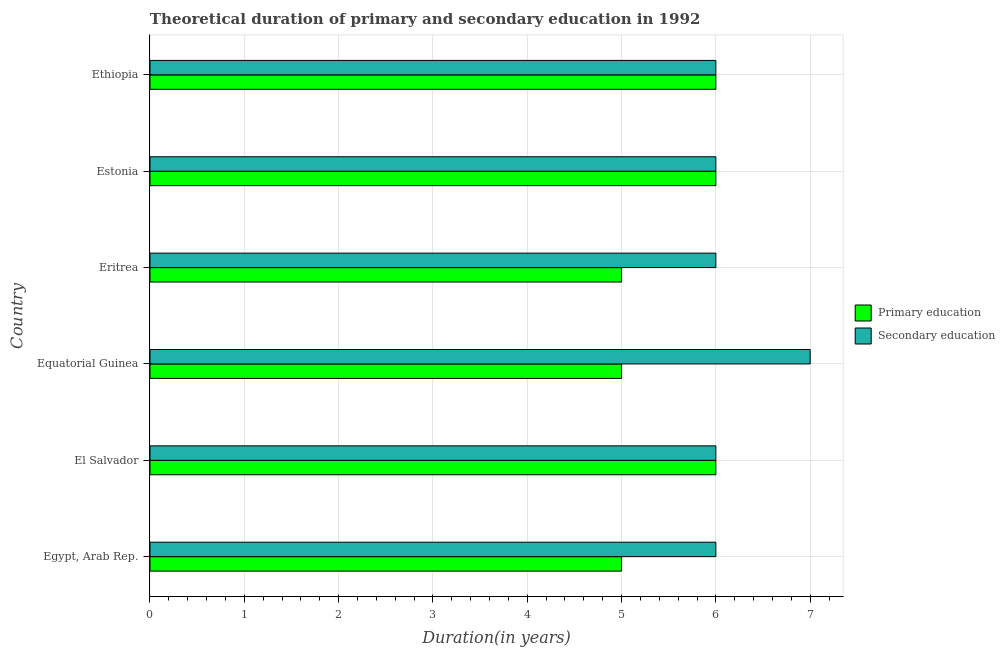How many groups of bars are there?
Keep it short and to the point. 6. Are the number of bars per tick equal to the number of legend labels?
Give a very brief answer. Yes. Are the number of bars on each tick of the Y-axis equal?
Give a very brief answer. Yes. How many bars are there on the 5th tick from the top?
Keep it short and to the point. 2. How many bars are there on the 4th tick from the bottom?
Your answer should be very brief. 2. What is the label of the 1st group of bars from the top?
Your answer should be compact. Ethiopia. In how many cases, is the number of bars for a given country not equal to the number of legend labels?
Give a very brief answer. 0. What is the duration of primary education in Eritrea?
Make the answer very short. 5. Across all countries, what is the maximum duration of secondary education?
Provide a short and direct response. 7. Across all countries, what is the minimum duration of primary education?
Provide a succinct answer. 5. In which country was the duration of primary education maximum?
Offer a terse response. El Salvador. In which country was the duration of primary education minimum?
Keep it short and to the point. Egypt, Arab Rep. What is the total duration of primary education in the graph?
Your answer should be compact. 33. What is the difference between the duration of primary education in Equatorial Guinea and that in Estonia?
Your answer should be compact. -1. What is the average duration of primary education per country?
Keep it short and to the point. 5.5. What is the difference between the duration of secondary education and duration of primary education in Egypt, Arab Rep.?
Give a very brief answer. 1. In how many countries, is the duration of primary education greater than 2.2 years?
Provide a succinct answer. 6. Is the duration of secondary education in Egypt, Arab Rep. less than that in Equatorial Guinea?
Keep it short and to the point. Yes. Is the difference between the duration of primary education in Egypt, Arab Rep. and Estonia greater than the difference between the duration of secondary education in Egypt, Arab Rep. and Estonia?
Provide a short and direct response. No. What is the difference between the highest and the second highest duration of primary education?
Your response must be concise. 0. What is the difference between the highest and the lowest duration of primary education?
Provide a short and direct response. 1. Is the sum of the duration of secondary education in El Salvador and Ethiopia greater than the maximum duration of primary education across all countries?
Your answer should be very brief. Yes. What does the 2nd bar from the bottom in Estonia represents?
Offer a terse response. Secondary education. How many bars are there?
Your answer should be compact. 12. How many countries are there in the graph?
Provide a short and direct response. 6. Are the values on the major ticks of X-axis written in scientific E-notation?
Offer a terse response. No. Where does the legend appear in the graph?
Provide a short and direct response. Center right. What is the title of the graph?
Keep it short and to the point. Theoretical duration of primary and secondary education in 1992. What is the label or title of the X-axis?
Provide a succinct answer. Duration(in years). What is the Duration(in years) in Secondary education in El Salvador?
Provide a short and direct response. 6. What is the Duration(in years) of Secondary education in Equatorial Guinea?
Your response must be concise. 7. What is the Duration(in years) in Primary education in Eritrea?
Offer a very short reply. 5. What is the Duration(in years) of Secondary education in Eritrea?
Offer a very short reply. 6. What is the Duration(in years) in Primary education in Ethiopia?
Make the answer very short. 6. Across all countries, what is the maximum Duration(in years) in Primary education?
Offer a terse response. 6. What is the total Duration(in years) of Secondary education in the graph?
Provide a short and direct response. 37. What is the difference between the Duration(in years) in Primary education in Egypt, Arab Rep. and that in Ethiopia?
Provide a short and direct response. -1. What is the difference between the Duration(in years) in Secondary education in Egypt, Arab Rep. and that in Ethiopia?
Offer a very short reply. 0. What is the difference between the Duration(in years) of Secondary education in El Salvador and that in Equatorial Guinea?
Your answer should be compact. -1. What is the difference between the Duration(in years) in Primary education in El Salvador and that in Eritrea?
Give a very brief answer. 1. What is the difference between the Duration(in years) of Secondary education in El Salvador and that in Estonia?
Offer a very short reply. 0. What is the difference between the Duration(in years) in Secondary education in Equatorial Guinea and that in Eritrea?
Keep it short and to the point. 1. What is the difference between the Duration(in years) in Primary education in Equatorial Guinea and that in Estonia?
Offer a terse response. -1. What is the difference between the Duration(in years) of Secondary education in Equatorial Guinea and that in Estonia?
Your response must be concise. 1. What is the difference between the Duration(in years) of Primary education in Equatorial Guinea and that in Ethiopia?
Make the answer very short. -1. What is the difference between the Duration(in years) in Secondary education in Equatorial Guinea and that in Ethiopia?
Keep it short and to the point. 1. What is the difference between the Duration(in years) of Secondary education in Eritrea and that in Estonia?
Keep it short and to the point. 0. What is the difference between the Duration(in years) of Primary education in Eritrea and that in Ethiopia?
Provide a succinct answer. -1. What is the difference between the Duration(in years) in Primary education in Egypt, Arab Rep. and the Duration(in years) in Secondary education in El Salvador?
Provide a short and direct response. -1. What is the difference between the Duration(in years) of Primary education in Egypt, Arab Rep. and the Duration(in years) of Secondary education in Equatorial Guinea?
Make the answer very short. -2. What is the difference between the Duration(in years) of Primary education in Egypt, Arab Rep. and the Duration(in years) of Secondary education in Eritrea?
Give a very brief answer. -1. What is the difference between the Duration(in years) in Primary education in Egypt, Arab Rep. and the Duration(in years) in Secondary education in Estonia?
Ensure brevity in your answer.  -1. What is the difference between the Duration(in years) in Primary education in Egypt, Arab Rep. and the Duration(in years) in Secondary education in Ethiopia?
Your answer should be very brief. -1. What is the difference between the Duration(in years) of Primary education in El Salvador and the Duration(in years) of Secondary education in Ethiopia?
Make the answer very short. 0. What is the difference between the Duration(in years) in Primary education in Equatorial Guinea and the Duration(in years) in Secondary education in Estonia?
Ensure brevity in your answer.  -1. What is the difference between the Duration(in years) of Primary education in Eritrea and the Duration(in years) of Secondary education in Estonia?
Your answer should be very brief. -1. What is the difference between the Duration(in years) of Primary education in Eritrea and the Duration(in years) of Secondary education in Ethiopia?
Offer a very short reply. -1. What is the difference between the Duration(in years) of Primary education in Estonia and the Duration(in years) of Secondary education in Ethiopia?
Your response must be concise. 0. What is the average Duration(in years) in Primary education per country?
Offer a terse response. 5.5. What is the average Duration(in years) in Secondary education per country?
Make the answer very short. 6.17. What is the difference between the Duration(in years) in Primary education and Duration(in years) in Secondary education in Egypt, Arab Rep.?
Ensure brevity in your answer.  -1. What is the difference between the Duration(in years) in Primary education and Duration(in years) in Secondary education in Eritrea?
Your answer should be very brief. -1. What is the difference between the Duration(in years) in Primary education and Duration(in years) in Secondary education in Estonia?
Your response must be concise. 0. What is the difference between the Duration(in years) of Primary education and Duration(in years) of Secondary education in Ethiopia?
Make the answer very short. 0. What is the ratio of the Duration(in years) of Secondary education in Egypt, Arab Rep. to that in Eritrea?
Offer a very short reply. 1. What is the ratio of the Duration(in years) of Primary education in Egypt, Arab Rep. to that in Ethiopia?
Keep it short and to the point. 0.83. What is the ratio of the Duration(in years) of Primary education in El Salvador to that in Eritrea?
Provide a succinct answer. 1.2. What is the ratio of the Duration(in years) in Secondary education in El Salvador to that in Eritrea?
Make the answer very short. 1. What is the ratio of the Duration(in years) in Primary education in El Salvador to that in Estonia?
Your answer should be very brief. 1. What is the ratio of the Duration(in years) of Primary education in El Salvador to that in Ethiopia?
Your response must be concise. 1. What is the ratio of the Duration(in years) of Secondary education in El Salvador to that in Ethiopia?
Keep it short and to the point. 1. What is the ratio of the Duration(in years) of Primary education in Equatorial Guinea to that in Eritrea?
Your answer should be compact. 1. What is the ratio of the Duration(in years) in Secondary education in Equatorial Guinea to that in Eritrea?
Your answer should be compact. 1.17. What is the ratio of the Duration(in years) in Primary education in Equatorial Guinea to that in Estonia?
Your answer should be very brief. 0.83. What is the ratio of the Duration(in years) of Secondary education in Equatorial Guinea to that in Estonia?
Make the answer very short. 1.17. What is the ratio of the Duration(in years) of Primary education in Eritrea to that in Ethiopia?
Offer a very short reply. 0.83. What is the ratio of the Duration(in years) of Secondary education in Eritrea to that in Ethiopia?
Keep it short and to the point. 1. What is the ratio of the Duration(in years) of Primary education in Estonia to that in Ethiopia?
Offer a very short reply. 1. What is the difference between the highest and the lowest Duration(in years) of Secondary education?
Give a very brief answer. 1. 